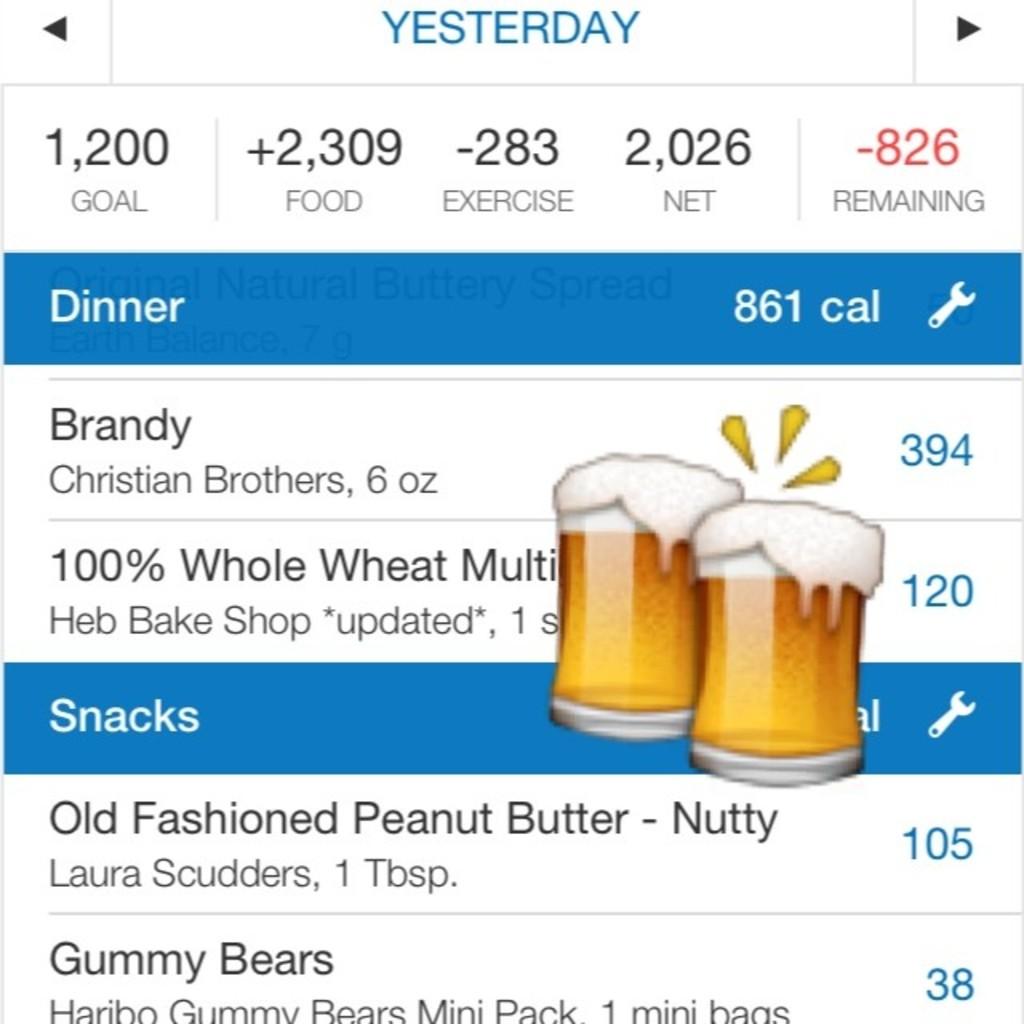How many calories does did yesterday's dinner contain?
Your answer should be compact. 861. 